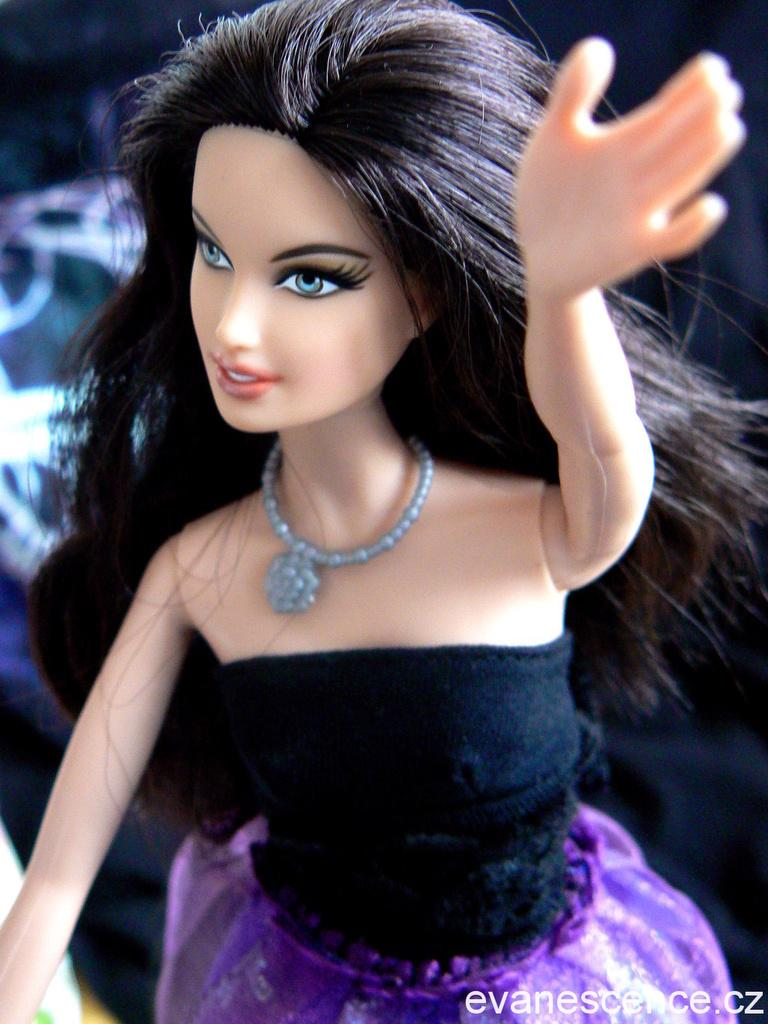What type of toy is in the image? There is a Barbie doll in the image. What is the Barbie doll wearing? The Barbie doll is wearing a purple dress. In which direction is the Barbie doll facing? The Barbie doll is facing towards the left. What type of plants can be seen growing in the background of the image? There are no plants visible in the image; it only features a Barbie doll. 